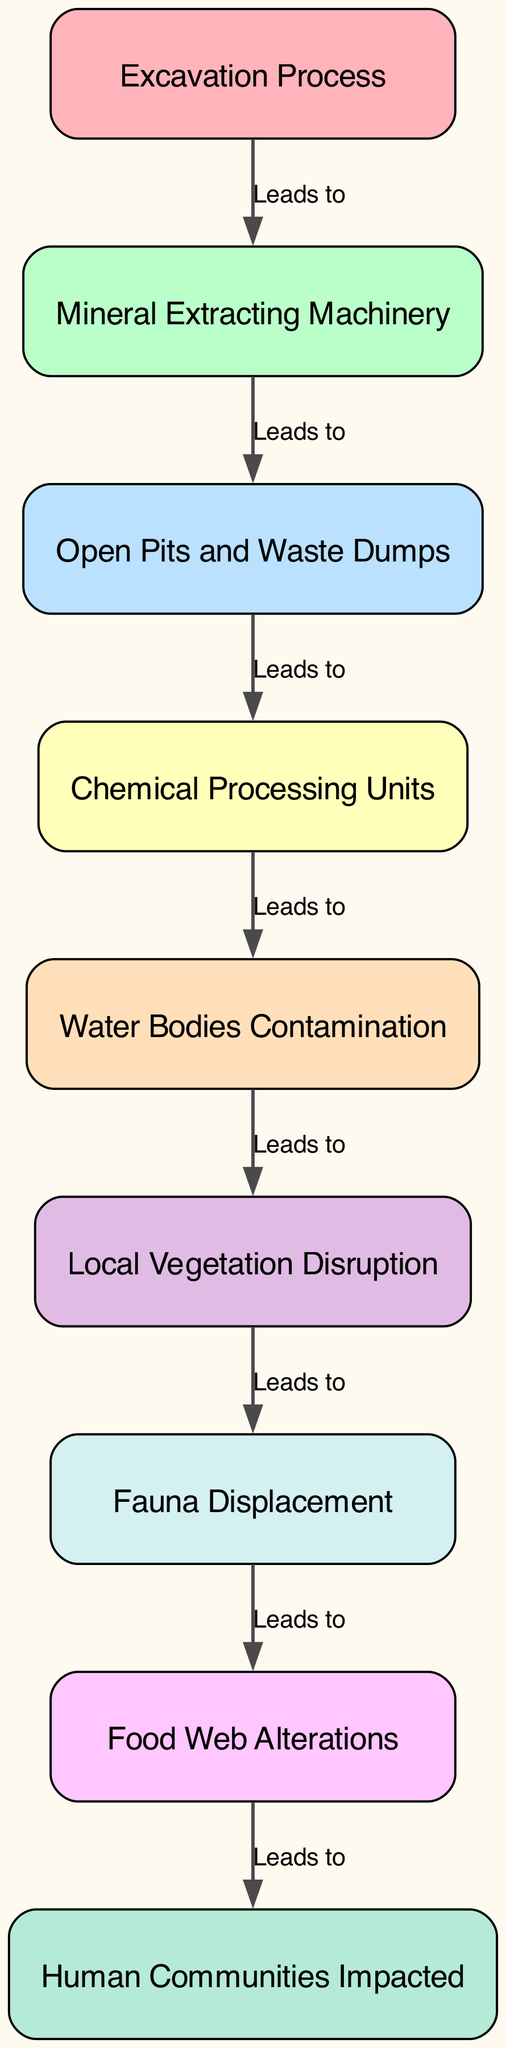What is the first element in the food chain? The first element listed in the food chain is "Excavation Process." By looking at the diagram, it is clear that this is the starting point, as it appears at the top of the flow.
Answer: Excavation Process How many nodes are in the diagram? The diagram contains a total of 9 nodes, as there are 9 elements in the provided data about the food chain showing their relationships.
Answer: 9 Which element leads to "Water Bodies Contamination"? The element that leads to "Water Bodies Contamination" is "Open Pits and Waste Dumps." In the flow of the diagram, there is a direct connection from this element to "Water Bodies Contamination," indicating a sequential effect.
Answer: Open Pits and Waste Dumps What relationship exists between "Local Vegetation Disruption" and "Excavation Process"? "Excavation Process" indirectly affects "Local Vegetation Disruption" through multiple steps in the chain. Specifically, after "Excavation Process," the following nodes lead to soil erosion and contamination, resulting in a disruption of local vegetation.
Answer: Indirect relationship Which two elements are impacted by "Food Web Alterations"? The two elements impacted by "Food Web Alterations" are "Local Vegetation Disruption" and "Fauna Displacement." The diagram shows that the changes in food web dynamics specifically lead to disruptions in both flora and fauna.
Answer: Local Vegetation Disruption, Fauna Displacement What element comes right before "Chemical Processing Units"? The element that comes right before "Chemical Processing Units" is "Mineral Extracting Machinery." This is evident by observing the sequential flow in the diagram and determining the direct predecessor.
Answer: Mineral Extracting Machinery Which two nodes are directly linked to "Human Communities Impacted"? The two nodes that are directly linked to "Human Communities Impacted" are "Food Web Alterations" and "Local Vegetation Disruption." The diagram illustrates how these two factors lead to impacts on human communities.
Answer: Food Web Alterations, Local Vegetation Disruption What element represents a consequence of contamination from mining activities? The element that represents a consequence of contamination from mining activities is "Water Bodies Contamination." This indicates the direct impact of mining runoff, which contaminates local water sources.
Answer: Water Bodies Contamination 